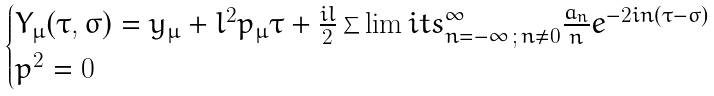Convert formula to latex. <formula><loc_0><loc_0><loc_500><loc_500>\begin{cases} Y _ { \mu } ( \tau , \sigma ) = y _ { \mu } + l ^ { 2 } p _ { \mu } \tau + \frac { i l } { 2 } \sum \lim i t s _ { n = - \infty \, ; \, n \neq 0 } ^ { \infty } \frac { a _ { n } } { n } e ^ { - 2 i n ( \tau - \sigma ) } \\ p ^ { 2 } = 0 \end{cases}</formula> 